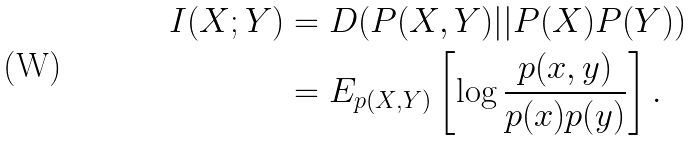<formula> <loc_0><loc_0><loc_500><loc_500>I ( X ; Y ) & = D ( P ( X , Y ) | | P ( X ) P ( Y ) ) \\ & = E _ { p ( X , Y ) } \left [ \log \frac { p ( x , y ) } { p ( x ) p ( y ) } \right ] .</formula> 